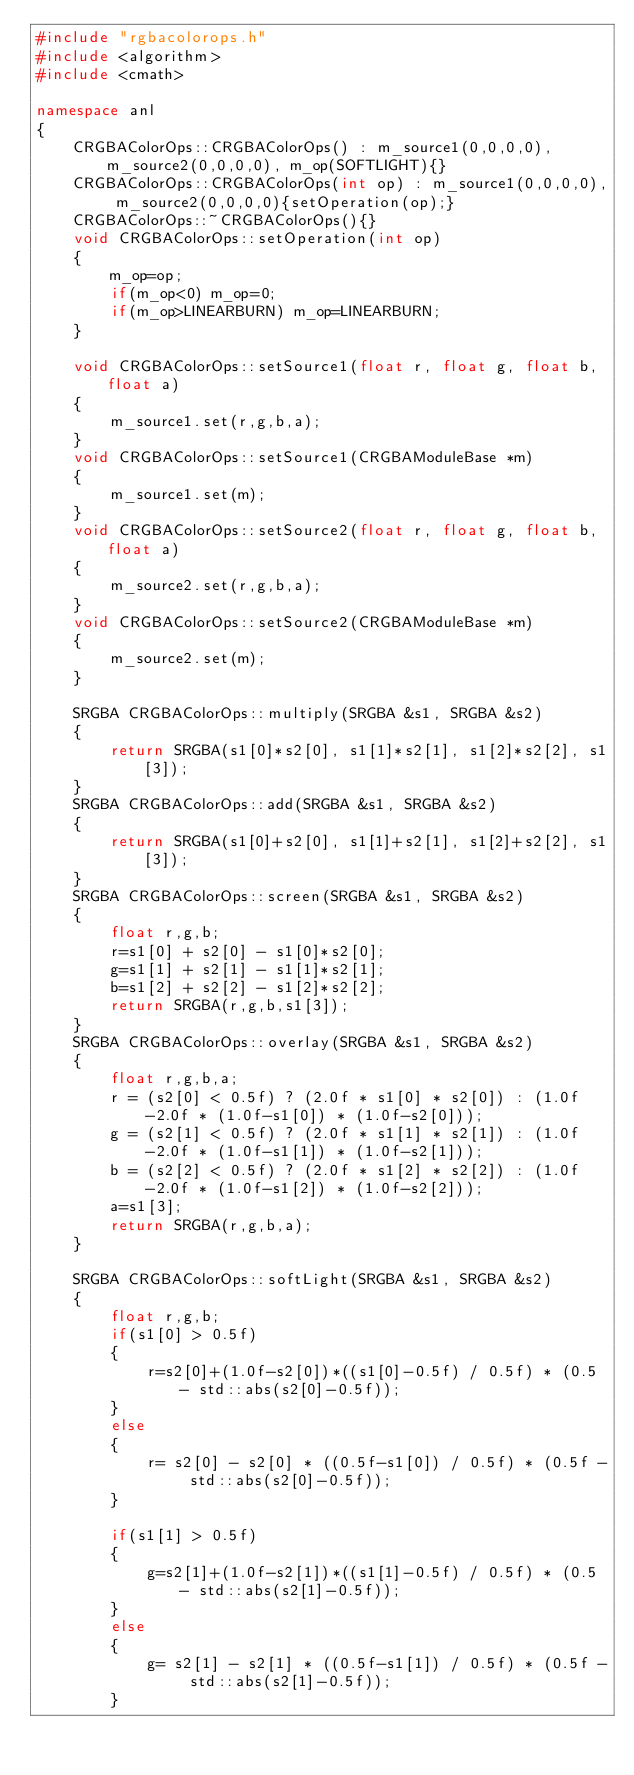<code> <loc_0><loc_0><loc_500><loc_500><_C++_>#include "rgbacolorops.h"
#include <algorithm>
#include <cmath>

namespace anl
{
    CRGBAColorOps::CRGBAColorOps() : m_source1(0,0,0,0), m_source2(0,0,0,0), m_op(SOFTLIGHT){}
    CRGBAColorOps::CRGBAColorOps(int op) : m_source1(0,0,0,0), m_source2(0,0,0,0){setOperation(op);}
    CRGBAColorOps::~CRGBAColorOps(){}
    void CRGBAColorOps::setOperation(int op)
    {
        m_op=op;
        if(m_op<0) m_op=0;
        if(m_op>LINEARBURN) m_op=LINEARBURN;
    }

    void CRGBAColorOps::setSource1(float r, float g, float b, float a)
    {
        m_source1.set(r,g,b,a);
    }
    void CRGBAColorOps::setSource1(CRGBAModuleBase *m)
    {
        m_source1.set(m);
    }
    void CRGBAColorOps::setSource2(float r, float g, float b, float a)
    {
        m_source2.set(r,g,b,a);
    }
    void CRGBAColorOps::setSource2(CRGBAModuleBase *m)
    {
        m_source2.set(m);
    }

    SRGBA CRGBAColorOps::multiply(SRGBA &s1, SRGBA &s2)
    {
        return SRGBA(s1[0]*s2[0], s1[1]*s2[1], s1[2]*s2[2], s1[3]);
    }
    SRGBA CRGBAColorOps::add(SRGBA &s1, SRGBA &s2)
    {
        return SRGBA(s1[0]+s2[0], s1[1]+s2[1], s1[2]+s2[2], s1[3]);
    }
    SRGBA CRGBAColorOps::screen(SRGBA &s1, SRGBA &s2)
    {
        float r,g,b;
        r=s1[0] + s2[0] - s1[0]*s2[0];
        g=s1[1] + s2[1] - s1[1]*s2[1];
        b=s1[2] + s2[2] - s1[2]*s2[2];
        return SRGBA(r,g,b,s1[3]);
    }
    SRGBA CRGBAColorOps::overlay(SRGBA &s1, SRGBA &s2)
    {
        float r,g,b,a;
        r = (s2[0] < 0.5f) ? (2.0f * s1[0] * s2[0]) : (1.0f-2.0f * (1.0f-s1[0]) * (1.0f-s2[0]));
        g = (s2[1] < 0.5f) ? (2.0f * s1[1] * s2[1]) : (1.0f-2.0f * (1.0f-s1[1]) * (1.0f-s2[1]));
        b = (s2[2] < 0.5f) ? (2.0f * s1[2] * s2[2]) : (1.0f-2.0f * (1.0f-s1[2]) * (1.0f-s2[2]));
        a=s1[3];
        return SRGBA(r,g,b,a);
    }

    SRGBA CRGBAColorOps::softLight(SRGBA &s1, SRGBA &s2)
    {
        float r,g,b;
        if(s1[0] > 0.5f)
        {
            r=s2[0]+(1.0f-s2[0])*((s1[0]-0.5f) / 0.5f) * (0.5 - std::abs(s2[0]-0.5f));
        }
        else
        {
            r= s2[0] - s2[0] * ((0.5f-s1[0]) / 0.5f) * (0.5f - std::abs(s2[0]-0.5f));
        }

        if(s1[1] > 0.5f)
        {
            g=s2[1]+(1.0f-s2[1])*((s1[1]-0.5f) / 0.5f) * (0.5 - std::abs(s2[1]-0.5f));
        }
        else
        {
            g= s2[1] - s2[1] * ((0.5f-s1[1]) / 0.5f) * (0.5f - std::abs(s2[1]-0.5f));
        }
</code> 